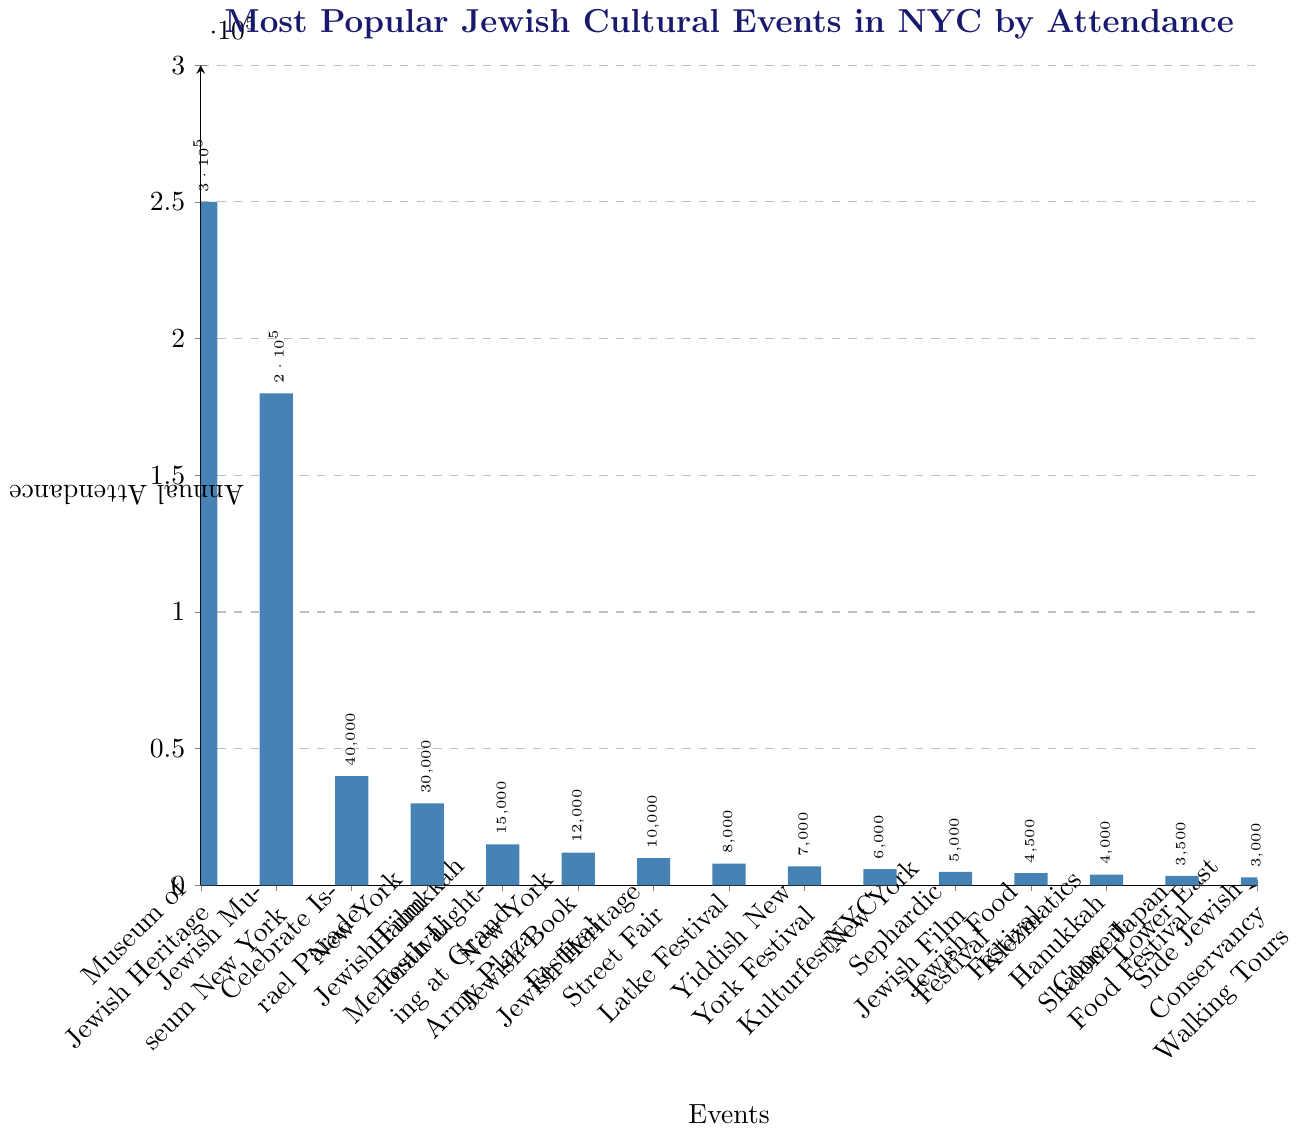What is the most popular Jewish cultural event in NYC by attendance? The Museum of Jewish Heritage has the highest bar height, indicating the largest annual attendance.
Answer: Museum of Jewish Heritage Which event has the lowest annual attendance? The Lower East Side Jewish Conservancy Walking Tours has the shortest bar, indicating the lowest attendance.
Answer: Lower East Side Jewish Conservancy Walking Tours How much larger is the attendance of the New York Jewish Film Festival compared to the Hanukkah Menorah Lighting at Grand Army Plaza? The annual attendance of the New York Jewish Film Festival is 30,000, while the Hanukkah Menorah Lighting at Grand Army Plaza is 15,000. The difference is 30,000 - 15,000 = 15,000.
Answer: 15,000 What is the combined annual attendance of the Celebrate Israel Parade and the Jewish Museum New York? The annual attendance for the Celebrate Israel Parade is 40,000 and for the Jewish Museum New York it is 180,000. The combined attendance is 40,000 + 180,000 = 220,000.
Answer: 220,000 Which event has higher attendance: the Latke Festival or the Yiddish New York Festival? The annual attendance for the Latke Festival is 8,000, whereas for the Yiddish New York Festival it is 7,000. The Latke Festival has a higher attendance.
Answer: Latke Festival Identify two events with an annual attendance of less than 5,000. The Jewish Food Festival (4,500) and the Klezmatics Hanukkah Concert (4,000) both have annual attendances under 5,000.
Answer: Jewish Food Festival, Klezmatics Hanukkah Concert What is the average annual attendance of the three most attended events? The three most attended events are Museum of Jewish Heritage (250,000), Jewish Museum New York (180,000), and Celebrate Israel Parade (40,000). The sum of these attendances is 470,000, and the average is 470,000 / 3 = 156,666.67, approximately.
Answer: 156,667 How much more popular is the Museum of Jewish Heritage compared to the New York Jewish Book Festival in terms of attendance? The annual attendance for the Museum of Jewish Heritage is 250,000, while for the New York Jewish Book Festival it is 12,000. The difference is 250,000 - 12,000 = 238,000.
Answer: 238,000 What is the combined attendance of events with less than 10,000 participants each? The events with less than 10,000 participants are: Jewish Heritage Street Fair (10,000), Latke Festival (8,000), Yiddish New York Festival (7,000), KulturfestNYC (6,000), New York Sephardic Jewish Film Festival (5,000), Jewish Food Festival (4,500), Klezmatics Hanukkah Concert (4,000), Shalom Japan Food Festival (3,500), Lower East Side Jewish Conservancy Walking Tours (3,000). Their combined attendance is 10,000 + 8,000 + 7,000 + 6,000 + 5,000 + 4,500 + 4,000 + 3,500 + 3,000 = 51,000.
Answer: 51,000 What is the range of the annual attendances represented in the chart? The range is the difference between the maximum and minimum values. The highest attendance is 250,000 (Museum of Jewish Heritage) and the lowest is 3,000 (Lower East Side Jewish Conservancy Walking Tours). The range is 250,000 - 3,000 = 247,000.
Answer: 247,000 